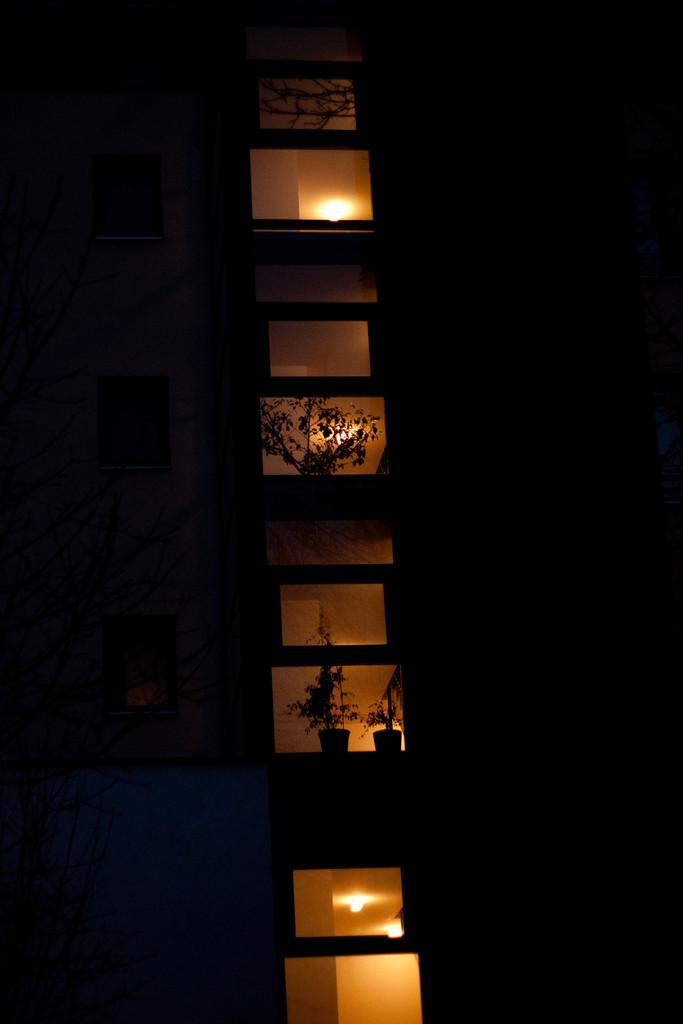What is the main structure visible in the image? There is a building in the image. Are there any decorative elements near the windows of the building? Yes, there are flower pots beside some of the windows on the building. What can be seen on the roofs of the building? There are lights attached to the roofs of the building. What type of recess is available for the residents of the building in the image? There is no information about a recess or any living spaces in the image; it only shows the exterior of the building. 